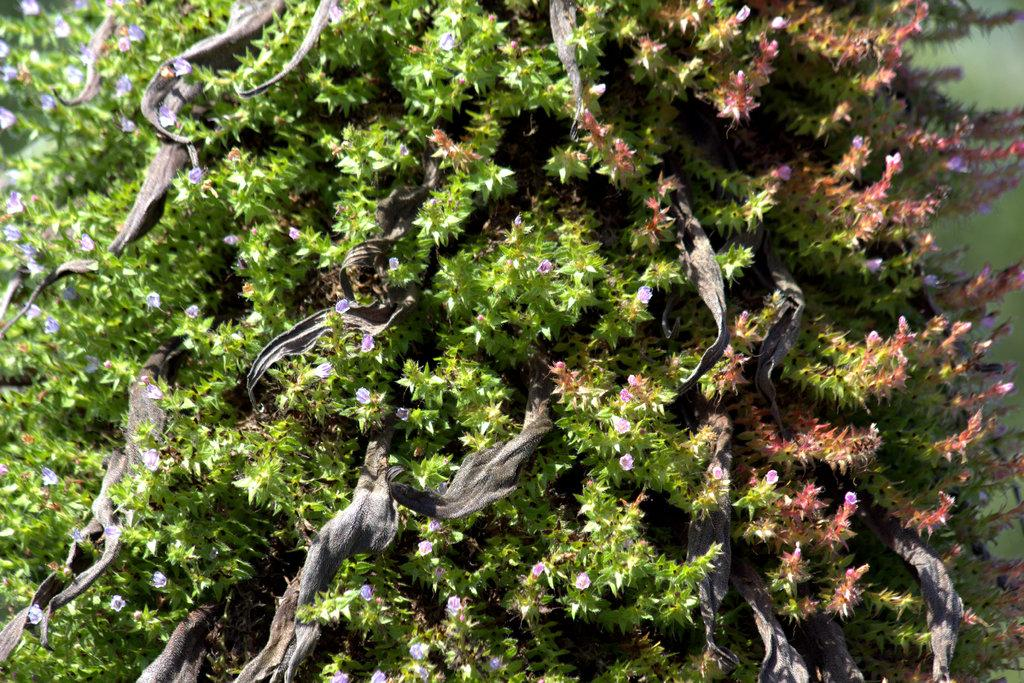What type of plant is the main subject in the image? There is a tree with flowers in the image. What can be seen in the background of the image? There is grass visible in the background of the image. How many donkeys are grazing in the grass in the image? There are no donkeys present in the image; it only features a tree with flowers and grass in the background. 